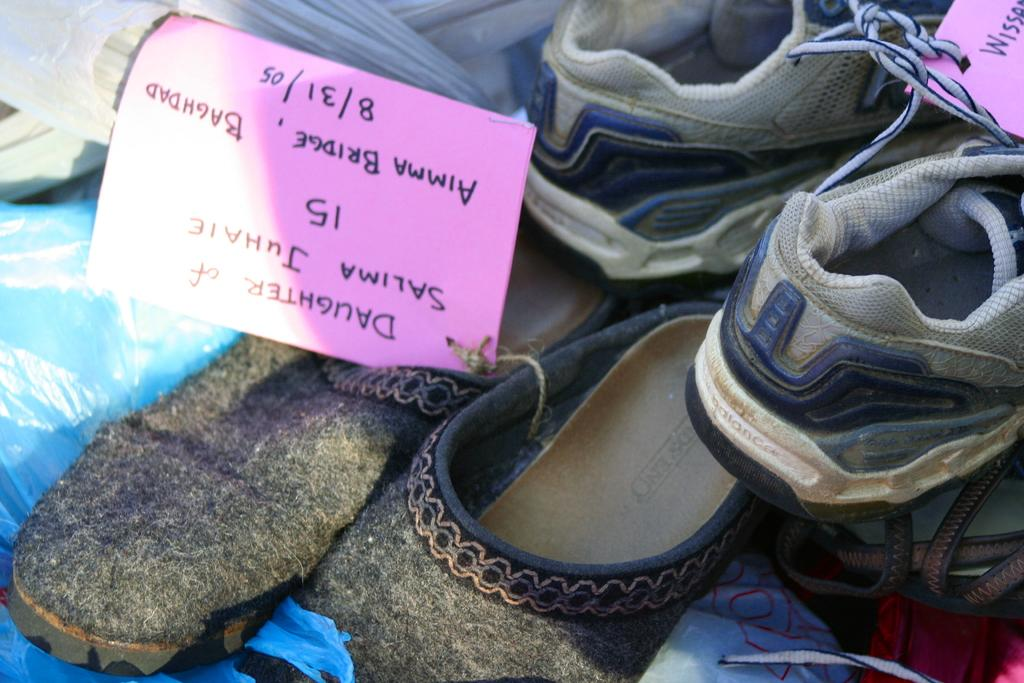What type of objects can be seen in the image? There are pairs of shoes and a paper with some note in the image. Can you describe the paper in the image? The paper has some note written on it. How many pairs of shoes are visible in the image? The number of pairs of shoes is not specified, but there are multiple pairs of shoes in the image. What type of door can be seen in the image? There is no door present in the image; it only features pairs of shoes and a paper with some note. 